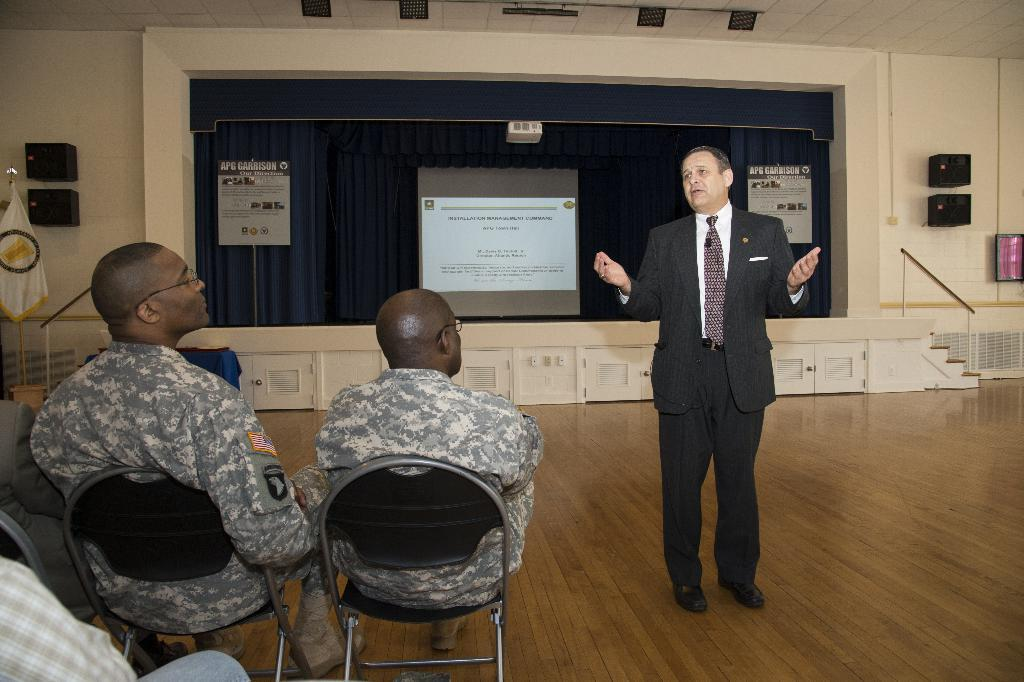What are the people in the image doing? The people in the image are sitting on chairs. Is there anyone standing in the image? Yes, there is a man standing in the image. What is located at the back of the scene? There is a projector screen at the back of the scene. What type of soup is being served for lunch in the image? There is no mention of soup or lunch in the image; it only shows people sitting on chairs, a standing man, and a projector screen. 